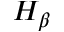Convert formula to latex. <formula><loc_0><loc_0><loc_500><loc_500>H _ { \beta }</formula> 